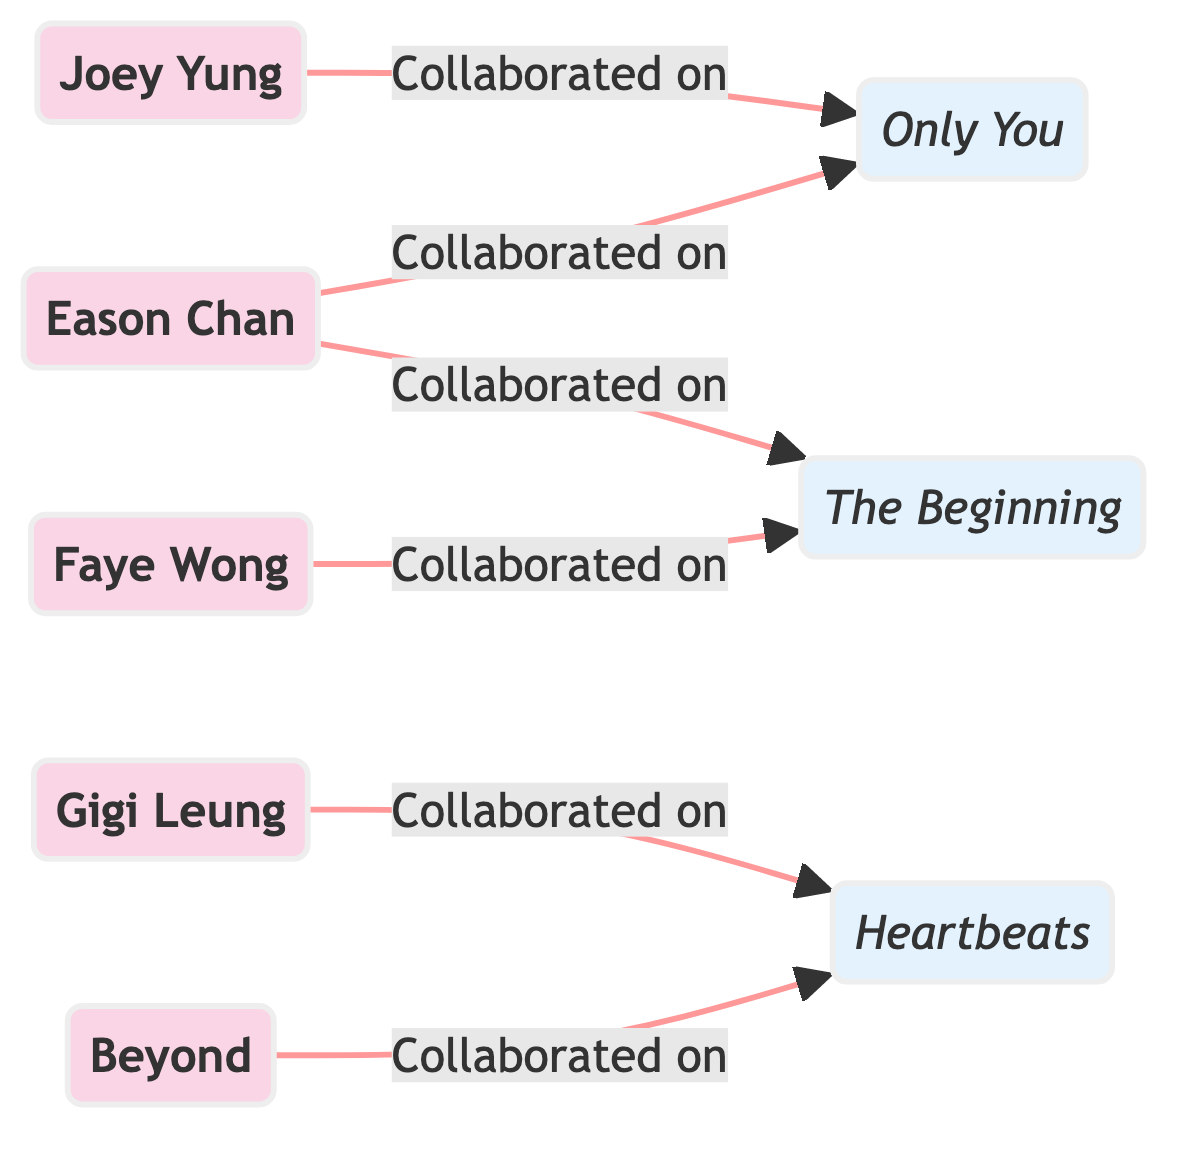What is the total number of artists in the diagram? Count the artist nodes in the diagram; they are Eason Chan, Joey Yung, Gigi Leung, Beyond, and Faye Wong, which adds up to 5 artists.
Answer: 5 Which album is a collaboration between Eason Chan and Joey Yung? Look for the album that both Eason Chan and Joey Yung point to; they both connect to the album labeled 'Only You'.
Answer: Only You How many collaboration albums are shown in the diagram? Identify the album nodes present; the diagram contains three album nodes: 'Only You', 'Heartbeats', and 'The Beginning', totaling 3 albums.
Answer: 3 Who collaborated with Gigi Leung on 'Heartbeats'? Examine which artist node has a directed edge pointing to the 'Heartbeats' album and discover that Gigi Leung collaborates with Beyond on this album.
Answer: Beyond Which album has Faye Wong as a collaborator? Find the album node that has a directed edge from Faye Wong; it is the album labeled 'The Beginning'.
Answer: The Beginning What is the relationship between Eason Chan and 'The Beginning'? Check the edges originating from Eason Chan; there’s a directed edge leading to the album 'The Beginning', indicating a collaboration.
Answer: Collaborated on How many edges (collaborations) connect artists to albums in the diagram? Count the directed edges in the diagram; there are a total of 6 edges connecting artists to their respective collaboration albums.
Answer: 6 Which artist is involved in the most collaboration albums? Review the directed edges; Eason Chan collaborates on two albums ('Only You' and 'The Beginning'), while others collaborate on one each.
Answer: Eason Chan What labels represent the collaboration albums in the diagram? Identify the album labels in the diagram; they are 'Only You', 'Heartbeats', and 'The Beginning'.
Answer: Only You, Heartbeats, The Beginning 